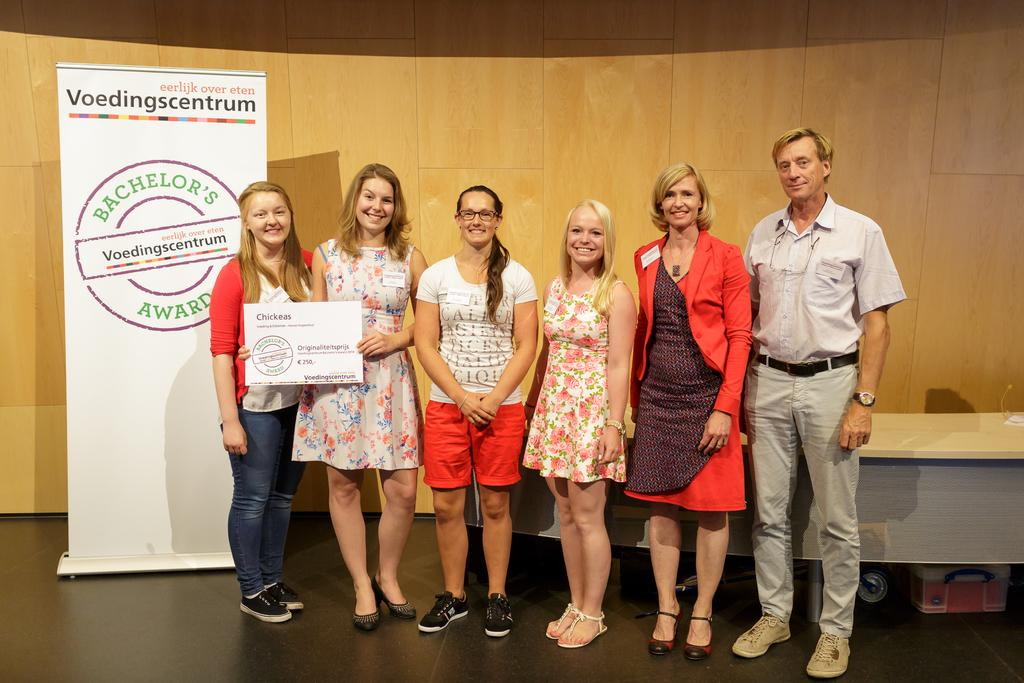What is happening in the image? There are people standing in the image. Can you describe what the woman is holding? The woman is holding a certificate in her hand. What can be seen on the left side of the image? There is an advertisement hoarding on the left side of the image. What is visible in the background of the image? There is a table in the background of the image. What type of stocking is the worm wearing in the image? There is no worm or stocking present in the image. 